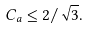Convert formula to latex. <formula><loc_0><loc_0><loc_500><loc_500>C _ { a } \leq 2 / \sqrt { 3 } .</formula> 